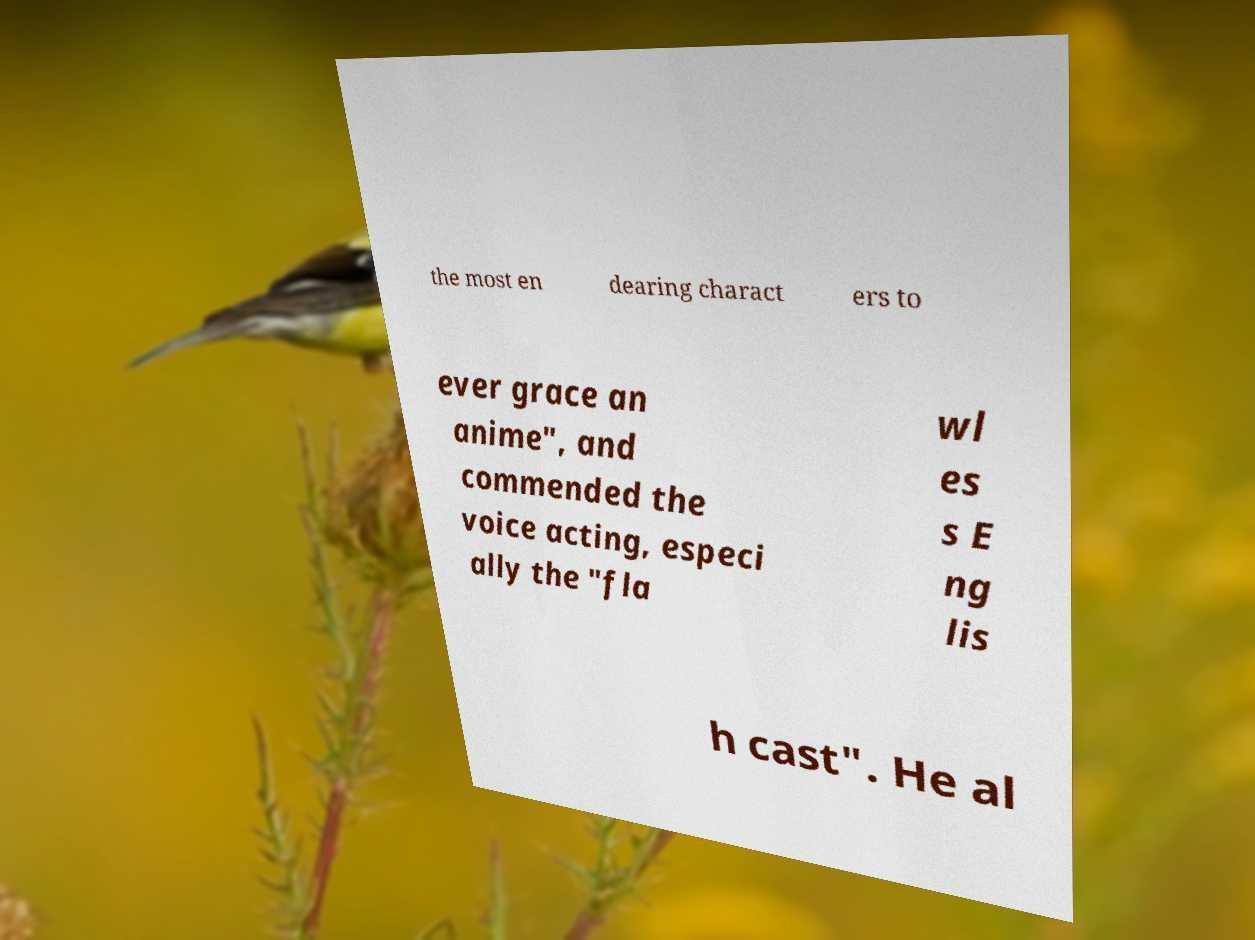Please read and relay the text visible in this image. What does it say? the most en dearing charact ers to ever grace an anime", and commended the voice acting, especi ally the "fla wl es s E ng lis h cast". He al 